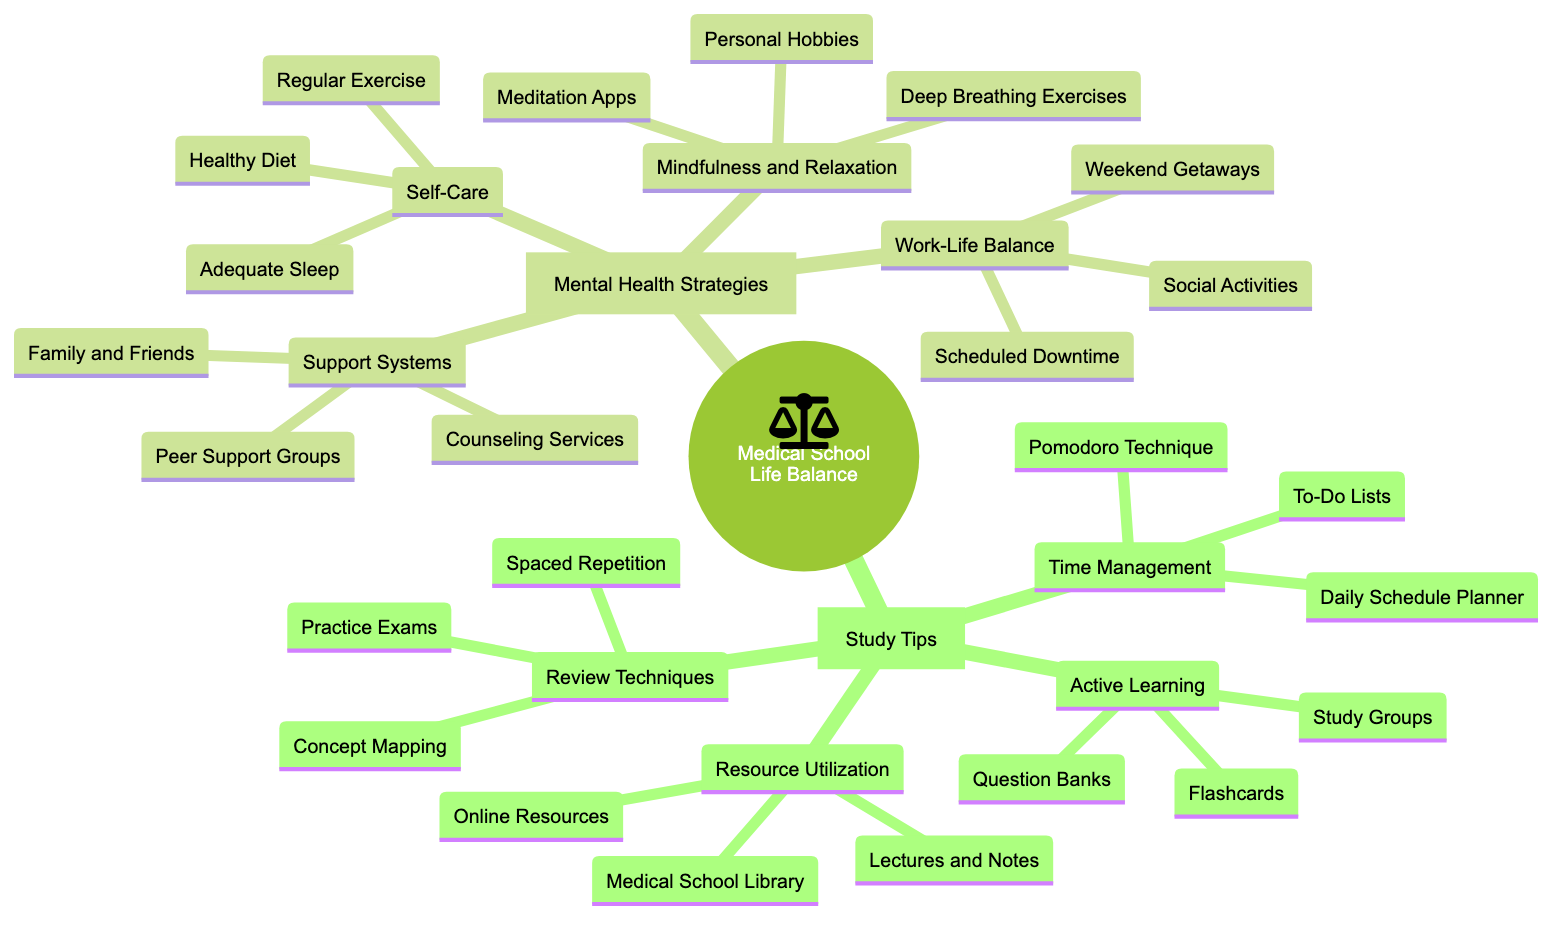What are two components of Active Learning? In the "Active Learning" section under "Study Tips," the components listed are "Flashcards (e.g., Anki)" and "Question Banks (e.g., UWorld)."
Answer: Flashcards, Question Banks How many main categories are listed under Mental Health Strategies? The "Mental Health Strategies" section contains four main categories: "Self-Care," "Mindfulness and Relaxation," "Support Systems," and "Work-Life Balance." Counting these gives a total of four.
Answer: 4 What is a technique included in Time Management? The "Time Management" section lists three techniques: "Pomodoro Technique," "Daily Schedule Planner (e.g., Google Calendar)," and "To-Do Lists." One of these techniques is "Pomodoro Technique."
Answer: Pomodoro Technique Which category includes "Regular Exercise"? "Regular Exercise" is listed under the "Self-Care" category, which is a part of the "Mental Health Strategies" section.
Answer: Self-Care What are two examples of Resource Utilization? The "Resource Utilization" category includes "Lectures and Notes" and "Online Resources (e.g., Khan Academy, Osmosis)" as its components.
Answer: Lectures and Notes, Online Resources How many total strategies are mentioned in the Work-Life Balance section? The "Work-Life Balance" section lists three components: "Scheduled Downtime," "Weekend Getaways," and "Social Activities." This totals three strategies.
Answer: 3 Which section has more items: Study Tips or Mental Health Strategies? The "Study Tips" section contains four categories, while the "Mental Health Strategies" section also has four categories. However, the components under each may differ. There are fewer items in "Mental Health Strategies" in total.
Answer: Study Tips Name an example of a Meditation App from the Mind Map. The "Mindfulness and Relaxation" section includes "Meditation Apps (e.g., Headspace, Calm)" as an example of tools for mindfulness, specifically calling out "Headspace" and "Calm" as main examples.
Answer: Headspace, Calm 